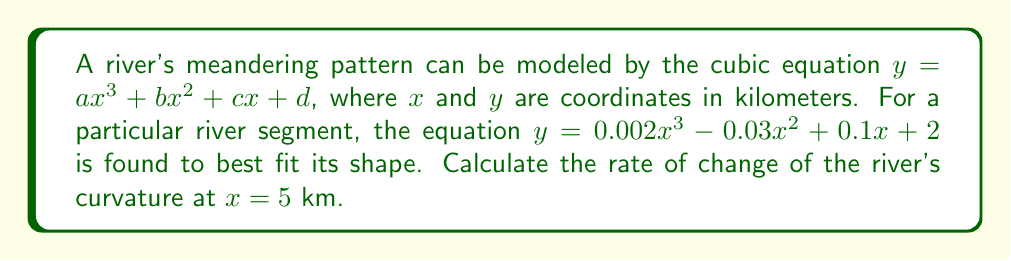Show me your answer to this math problem. To solve this problem, we need to follow these steps:

1) The curvature of a curve is given by the formula:

   $$\kappa = \frac{|y''|}{(1 + (y')^2)^{3/2}}$$

   where $y'$ and $y''$ are the first and second derivatives of $y$ with respect to $x$.

2) First, let's find $y'$:
   $$y' = 0.006x^2 - 0.06x + 0.1$$

3) Now, let's find $y''$:
   $$y'' = 0.012x - 0.06$$

4) To find the rate of change of curvature, we need to differentiate $\kappa$ with respect to $x$. This is a complex calculation, so we'll use the quotient rule and chain rule.

5) Let's call the numerator of $\kappa$ as $u = |y''|$ and the denominator as $v = (1 + (y')^2)^{3/2}$.

6) The derivative of $\kappa$ is:

   $$\frac{d\kappa}{dx} = \frac{v\frac{du}{dx} - u\frac{dv}{dx}}{v^2}$$

7) At $x = 5$:
   $y' = 0.006(5^2) - 0.06(5) + 0.1 = 0.15 - 0.3 + 0.1 = -0.05$
   $y'' = 0.012(5) - 0.06 = 0$

8) Since $y'' = 0$ at $x = 5$, the rate of change of curvature at this point is 0.
Answer: 0 